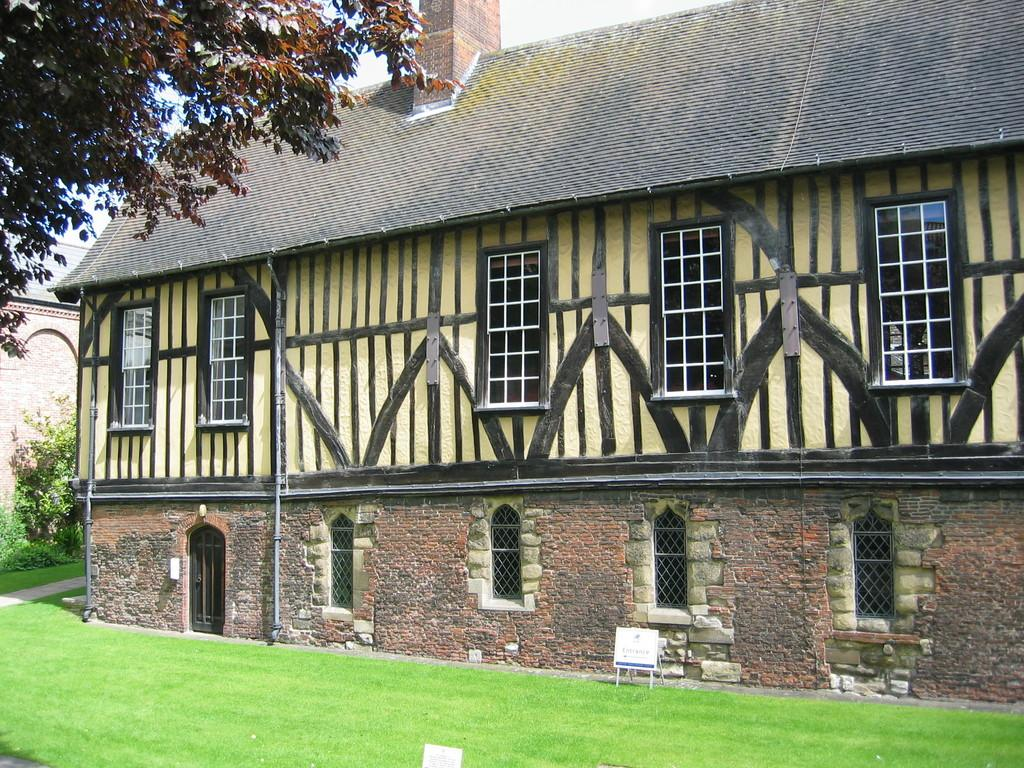What type of structures can be seen in the image? There are buildings in the image. What feature is present on the buildings? There are windows in the image. What type of vegetation is present in the image? There is grass, plants, and trees in the image. What is visible element separates the image from its surroundings? There is a border in the image. What part of the natural environment is visible in the image? The sky is visible in the image. Based on the presence of the sky and the absence of artificial lighting, when do you think the image was taken? The image was likely taken during the day. Can you see any birds nesting in the trees in the image? There is no indication of birds or nests in the trees in the image. Are there any people swimming in the image? There is no water or indication of swimming in the image. 